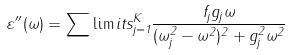Convert formula to latex. <formula><loc_0><loc_0><loc_500><loc_500>\varepsilon ^ { \prime \prime } ( \omega ) = \sum \lim i t s _ { j = 1 } ^ { K } \frac { f _ { j } g _ { j } \omega } { ( \omega _ { j } ^ { 2 } - \omega ^ { 2 } ) ^ { 2 } + g _ { j } ^ { 2 } \omega ^ { 2 } }</formula> 